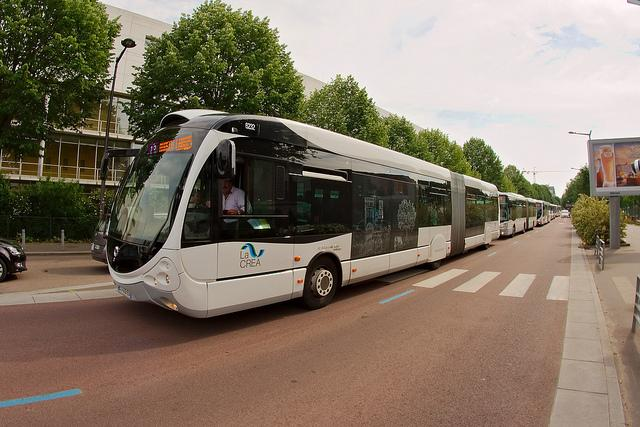What do the white markings on the road allow for here?

Choices:
A) crossing street
B) turning left
C) speeding up
D) turning right crossing street 